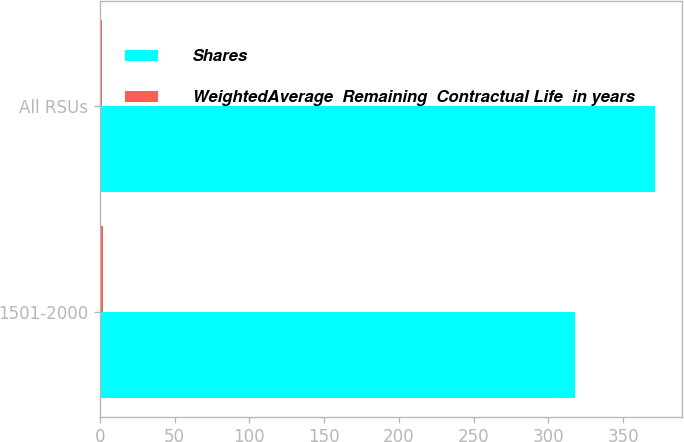Convert chart to OTSL. <chart><loc_0><loc_0><loc_500><loc_500><stacked_bar_chart><ecel><fcel>1501-2000<fcel>All RSUs<nl><fcel>Shares<fcel>318<fcel>371<nl><fcel>WeightedAverage  Remaining  Contractual Life  in years<fcel>1.8<fcel>1.6<nl></chart> 